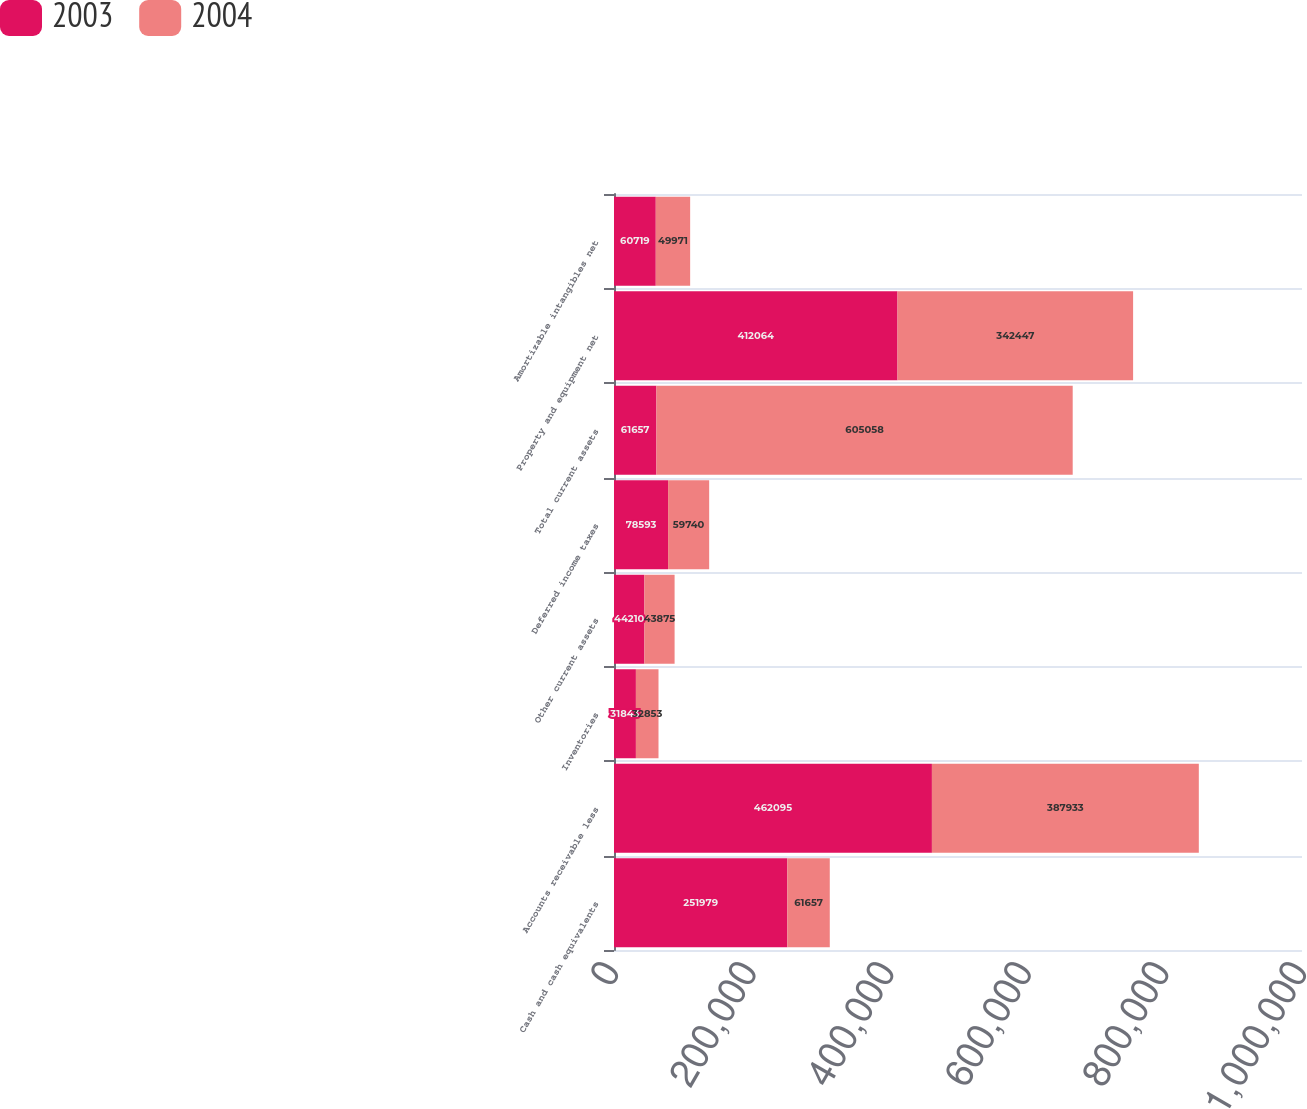<chart> <loc_0><loc_0><loc_500><loc_500><stacked_bar_chart><ecel><fcel>Cash and cash equivalents<fcel>Accounts receivable less<fcel>Inventories<fcel>Other current assets<fcel>Deferred income taxes<fcel>Total current assets<fcel>Property and equipment net<fcel>Amortizable intangibles net<nl><fcel>2003<fcel>251979<fcel>462095<fcel>31843<fcel>44210<fcel>78593<fcel>61657<fcel>412064<fcel>60719<nl><fcel>2004<fcel>61657<fcel>387933<fcel>32853<fcel>43875<fcel>59740<fcel>605058<fcel>342447<fcel>49971<nl></chart> 